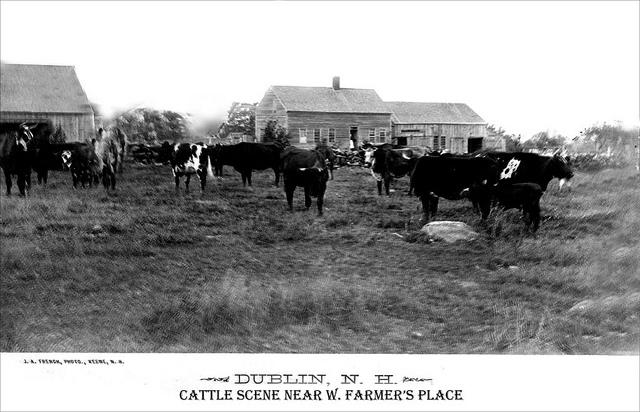Do any of the mainly solid colored cattle discriminate against the more dappled colored cattle?
Concise answer only. No. Where was this picture taken?
Concise answer only. Dublin, nh. Are the buildings new?
Short answer required. No. 